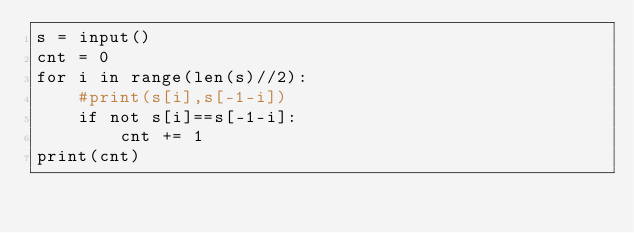<code> <loc_0><loc_0><loc_500><loc_500><_Python_>s = input()
cnt = 0
for i in range(len(s)//2):
    #print(s[i],s[-1-i])
    if not s[i]==s[-1-i]:
        cnt += 1
print(cnt)</code> 